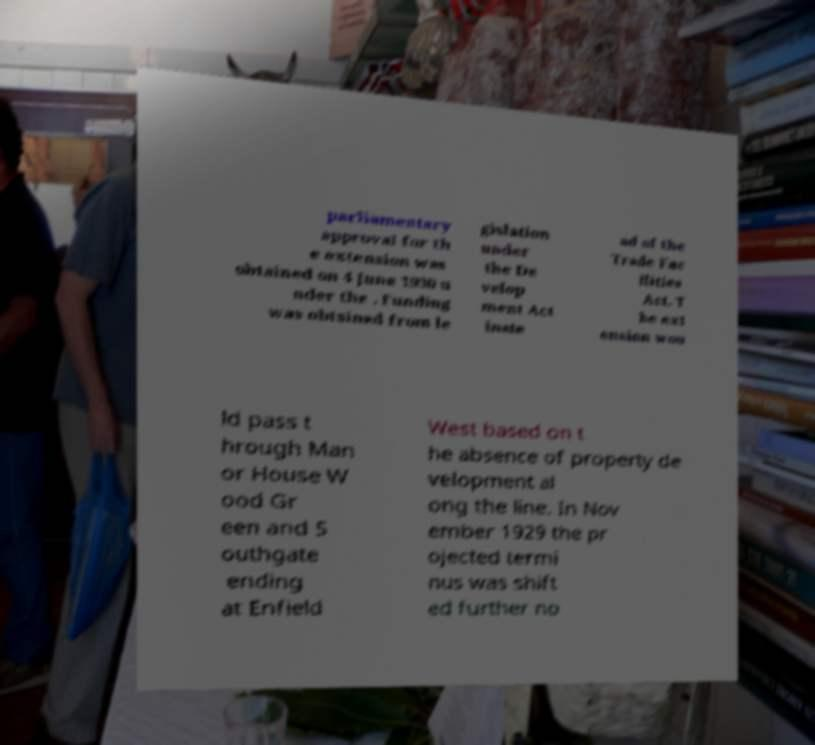Could you extract and type out the text from this image? parliamentary approval for th e extension was obtained on 4 June 1930 u nder the . Funding was obtained from le gislation under the De velop ment Act inste ad of the Trade Fac ilities Act. T he ext ension wou ld pass t hrough Man or House W ood Gr een and S outhgate ending at Enfield West based on t he absence of property de velopment al ong the line. In Nov ember 1929 the pr ojected termi nus was shift ed further no 